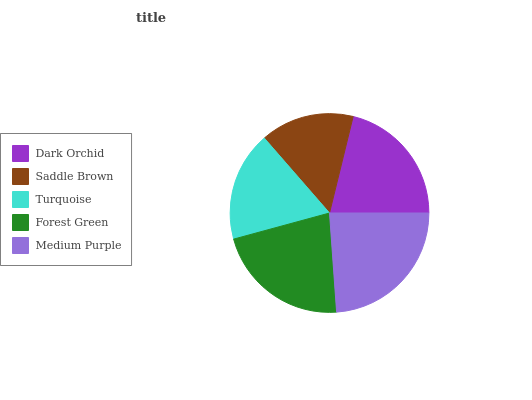Is Saddle Brown the minimum?
Answer yes or no. Yes. Is Medium Purple the maximum?
Answer yes or no. Yes. Is Turquoise the minimum?
Answer yes or no. No. Is Turquoise the maximum?
Answer yes or no. No. Is Turquoise greater than Saddle Brown?
Answer yes or no. Yes. Is Saddle Brown less than Turquoise?
Answer yes or no. Yes. Is Saddle Brown greater than Turquoise?
Answer yes or no. No. Is Turquoise less than Saddle Brown?
Answer yes or no. No. Is Dark Orchid the high median?
Answer yes or no. Yes. Is Dark Orchid the low median?
Answer yes or no. Yes. Is Forest Green the high median?
Answer yes or no. No. Is Medium Purple the low median?
Answer yes or no. No. 